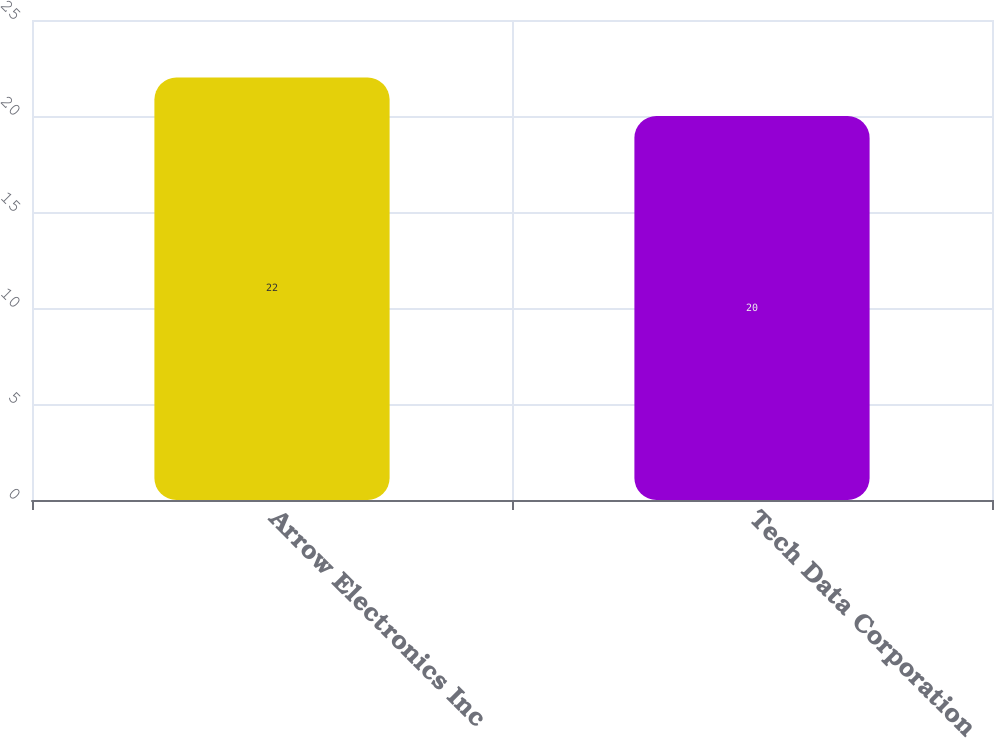Convert chart. <chart><loc_0><loc_0><loc_500><loc_500><bar_chart><fcel>Arrow Electronics Inc<fcel>Tech Data Corporation<nl><fcel>22<fcel>20<nl></chart> 